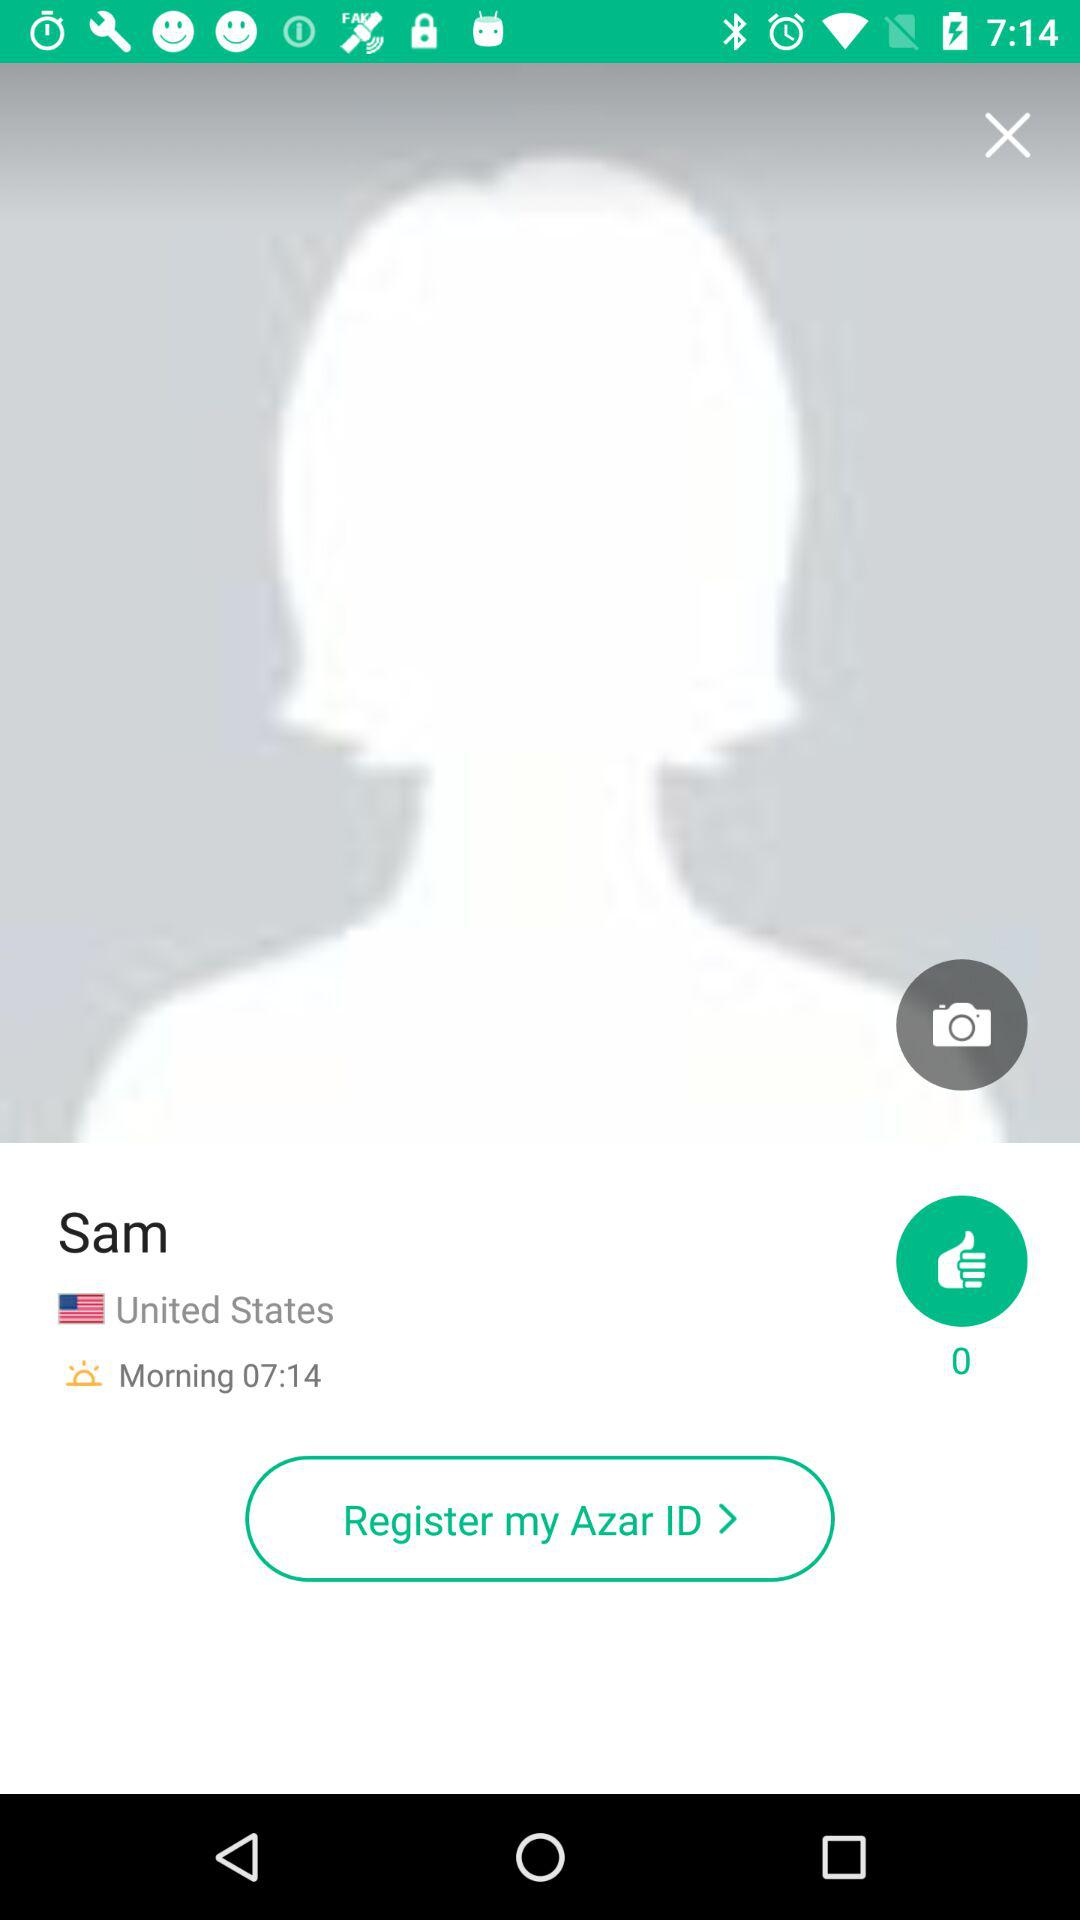What is the user name? The user name is Sam. 